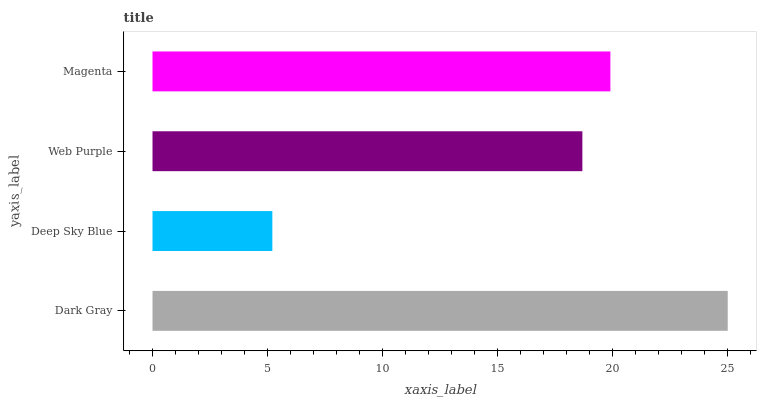Is Deep Sky Blue the minimum?
Answer yes or no. Yes. Is Dark Gray the maximum?
Answer yes or no. Yes. Is Web Purple the minimum?
Answer yes or no. No. Is Web Purple the maximum?
Answer yes or no. No. Is Web Purple greater than Deep Sky Blue?
Answer yes or no. Yes. Is Deep Sky Blue less than Web Purple?
Answer yes or no. Yes. Is Deep Sky Blue greater than Web Purple?
Answer yes or no. No. Is Web Purple less than Deep Sky Blue?
Answer yes or no. No. Is Magenta the high median?
Answer yes or no. Yes. Is Web Purple the low median?
Answer yes or no. Yes. Is Dark Gray the high median?
Answer yes or no. No. Is Dark Gray the low median?
Answer yes or no. No. 